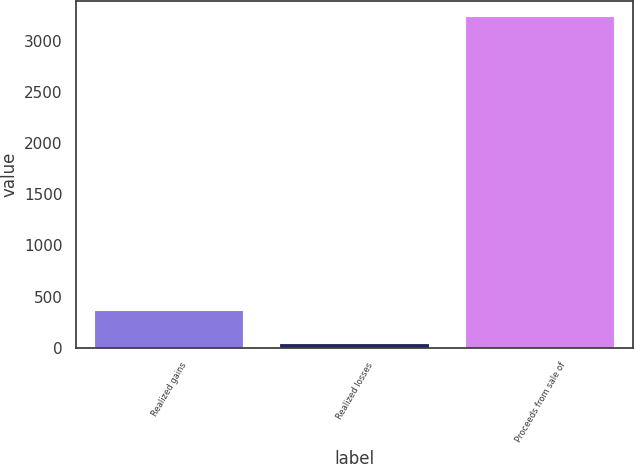<chart> <loc_0><loc_0><loc_500><loc_500><bar_chart><fcel>Realized gains<fcel>Realized losses<fcel>Proceeds from sale of<nl><fcel>357.3<fcel>38<fcel>3231<nl></chart> 